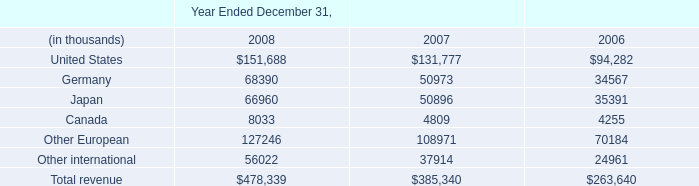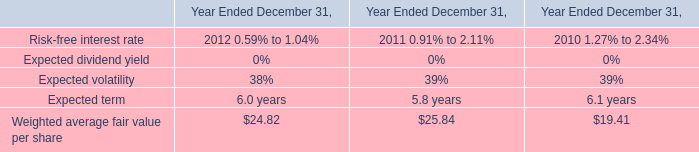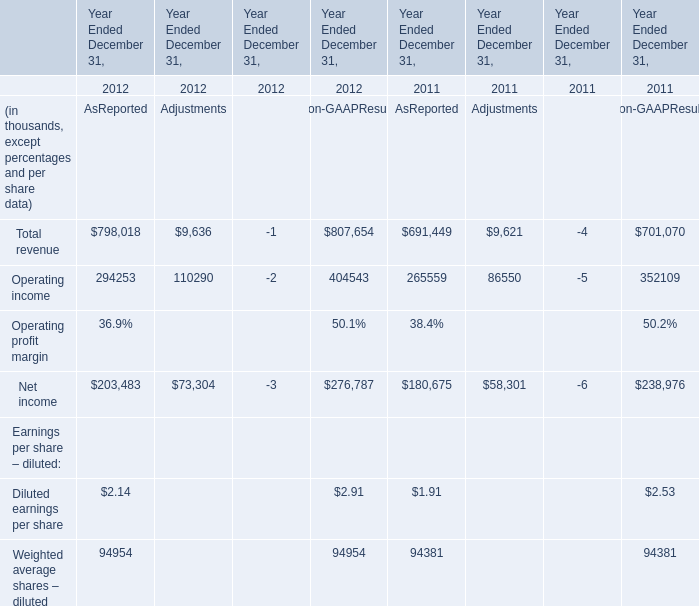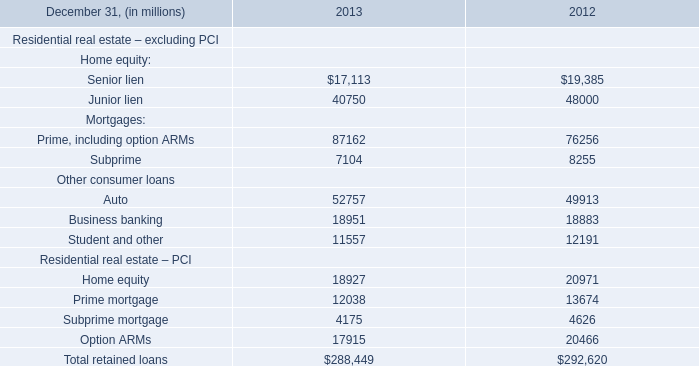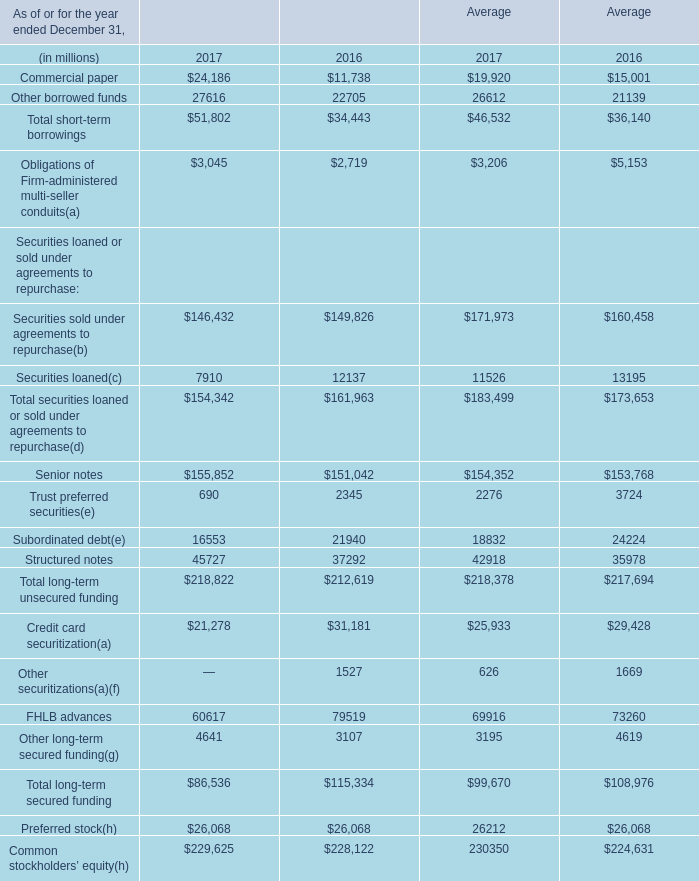What is the sum of the Structured notes in the years where FHLB advances is positive? (in million) 
Computations: (45727 + 37292)
Answer: 83019.0. 